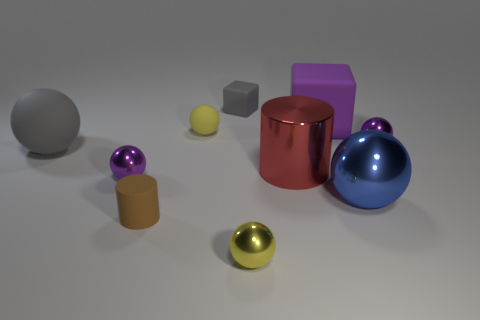Can you describe the colors of the objects and suggest what mood or atmosphere they create? The objects exhibit a range of colors such as purple, red, blue, yellow, and gray, each contributing to a vibrant yet harmonious composition. The cool tones of blue and purple can evoke a sense of calmness, while the warm tones of red and yellow add a touch of energy. Overall, this balanced color palette creates an inviting and playful atmosphere. 